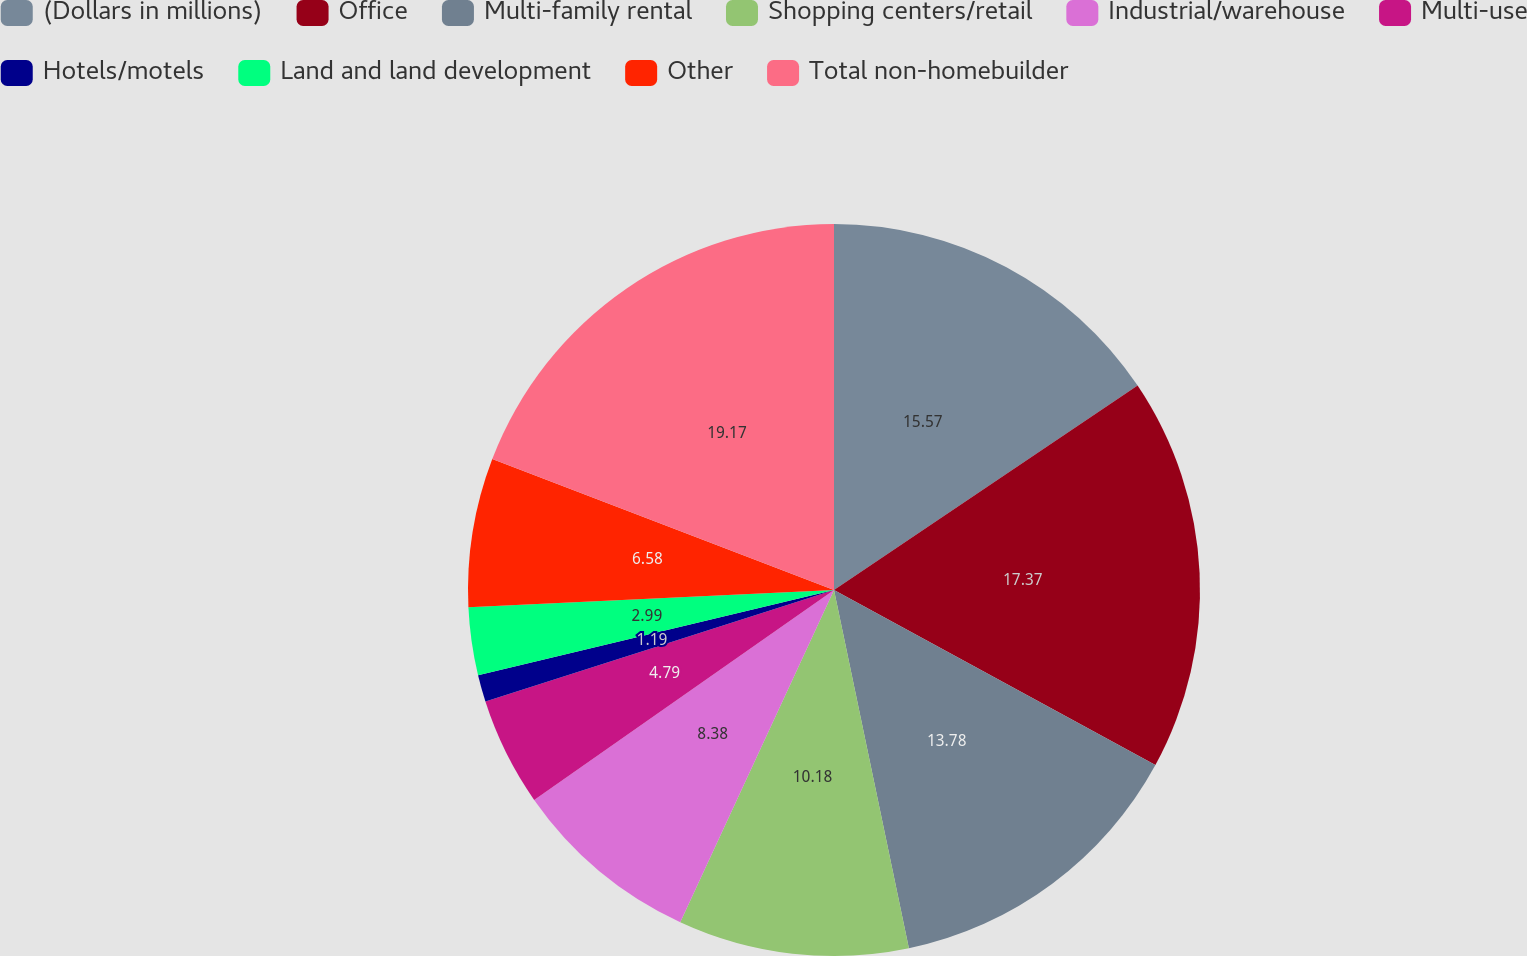Convert chart to OTSL. <chart><loc_0><loc_0><loc_500><loc_500><pie_chart><fcel>(Dollars in millions)<fcel>Office<fcel>Multi-family rental<fcel>Shopping centers/retail<fcel>Industrial/warehouse<fcel>Multi-use<fcel>Hotels/motels<fcel>Land and land development<fcel>Other<fcel>Total non-homebuilder<nl><fcel>15.57%<fcel>17.37%<fcel>13.78%<fcel>10.18%<fcel>8.38%<fcel>4.79%<fcel>1.19%<fcel>2.99%<fcel>6.58%<fcel>19.17%<nl></chart> 